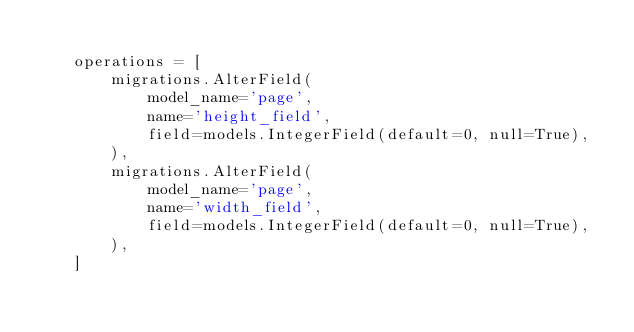<code> <loc_0><loc_0><loc_500><loc_500><_Python_>
    operations = [
        migrations.AlterField(
            model_name='page',
            name='height_field',
            field=models.IntegerField(default=0, null=True),
        ),
        migrations.AlterField(
            model_name='page',
            name='width_field',
            field=models.IntegerField(default=0, null=True),
        ),
    ]
</code> 